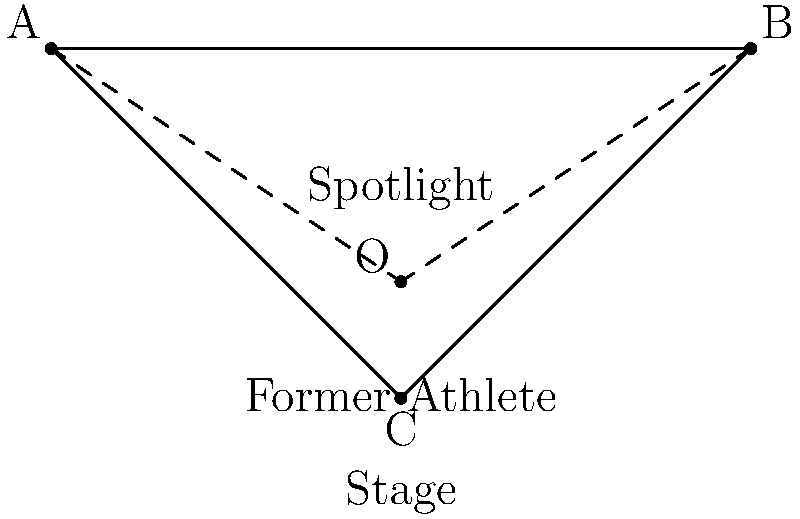A former basketball star is making his debut as a singer at a concert. The stage lighting technician needs to adjust the spotlight to illuminate the performer properly. Given the ray diagram above, where O represents the spotlight source, and C represents the position of the performer, what type of mirror should be used to create a wide, evenly distributed light beam from points A to B? To determine the appropriate mirror type for this stage lighting setup, let's analyze the situation step-by-step:

1. The goal is to create a wide, evenly distributed light beam from points A to B, originating from the spotlight at point O.

2. The ray diagram shows diverging light rays from point O to points A and B.

3. To achieve this diverging effect, we need a mirror that can spread out the light rays.

4. There are two main types of mirrors: concave and convex.
   - Concave mirrors tend to converge light rays.
   - Convex mirrors tend to diverge light rays.

5. In this case, we want to diverge the light rays to cover a wide area of the stage.

6. A convex mirror would be ideal for this purpose because:
   - It reflects light outwards, creating a diverging beam.
   - It produces a virtual, upright image that appears smaller and farther away than the object.
   - This property allows for a wider coverage area, which is perfect for stage lighting.

7. Using a convex mirror would ensure that the former athlete is well-illuminated across a broad area of the stage, enhancing visibility for the audience and creating an impressive visual effect for the performance.
Answer: Convex mirror 